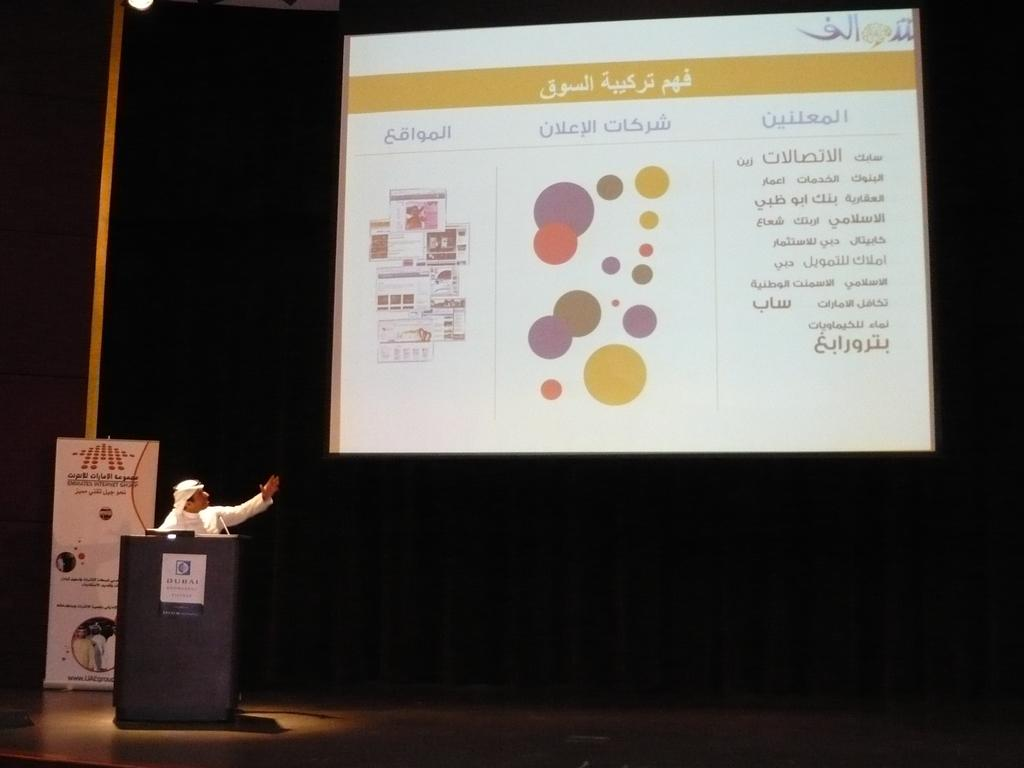Who is the person in the image? There is a man in the image. Where is the man located in the image? The man is standing near a desk. What is the man doing in the image? The man is giving a seminar. What is the man wearing in the image? The man is wearing a white dress. What is behind the man in the image? There is a screen behind the man. What is displayed on the screen in the image? The screen displays some information. What type of wire can be seen connecting the man to the screen in the image? There is no wire connecting the man to the screen in the image. 